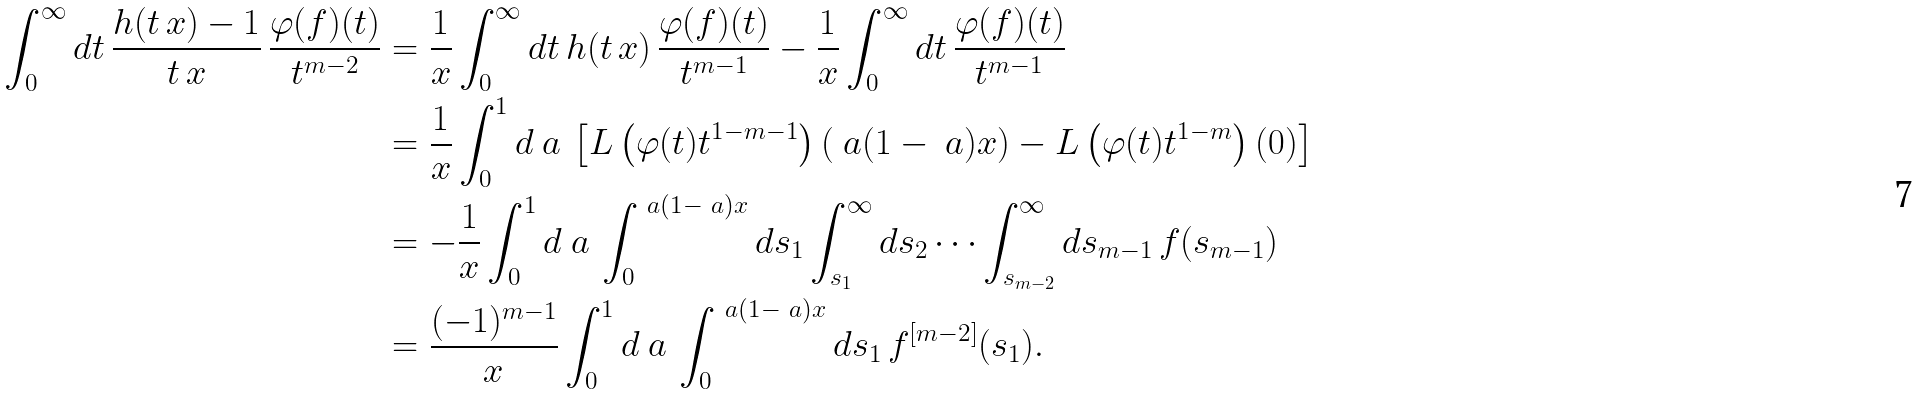Convert formula to latex. <formula><loc_0><loc_0><loc_500><loc_500>\int _ { 0 } ^ { \infty } d t \, \frac { h ( t \, x ) - 1 } { t \, x } \, \frac { \varphi ( f ) ( t ) } { t ^ { m - 2 } } & = \frac { 1 } { x } \int _ { 0 } ^ { \infty } d t \, h ( t \, x ) \, \frac { \varphi ( f ) ( t ) } { t ^ { m - 1 } } - \frac { 1 } { x } \int _ { 0 } ^ { \infty } d t \, \frac { \varphi ( f ) ( t ) } { t ^ { m - 1 } } \\ & = \frac { 1 } { x } \int _ { 0 } ^ { 1 } d \ a \, \left [ L \left ( \varphi ( t ) t ^ { 1 - m - 1 } \right ) \left ( \ a ( 1 - \ a ) x \right ) - L \left ( \varphi ( t ) t ^ { 1 - m } \right ) ( 0 ) \right ] \\ & = - \frac { 1 } { x } \int _ { 0 } ^ { 1 } d \ a \, \int _ { 0 } ^ { \ a ( 1 - \ a ) x } d s _ { 1 } \int _ { s _ { 1 } } ^ { \infty } d s _ { 2 } \cdots \int _ { s _ { m - 2 } } ^ { \infty } d s _ { m - 1 } \, f ( s _ { m - 1 } ) \\ & = \frac { ( - 1 ) ^ { m - 1 } } { x } \int _ { 0 } ^ { 1 } d \ a \, \int _ { 0 } ^ { \ a ( 1 - \ a ) x } d s _ { 1 } \, f ^ { [ m - 2 ] } ( s _ { 1 } ) .</formula> 